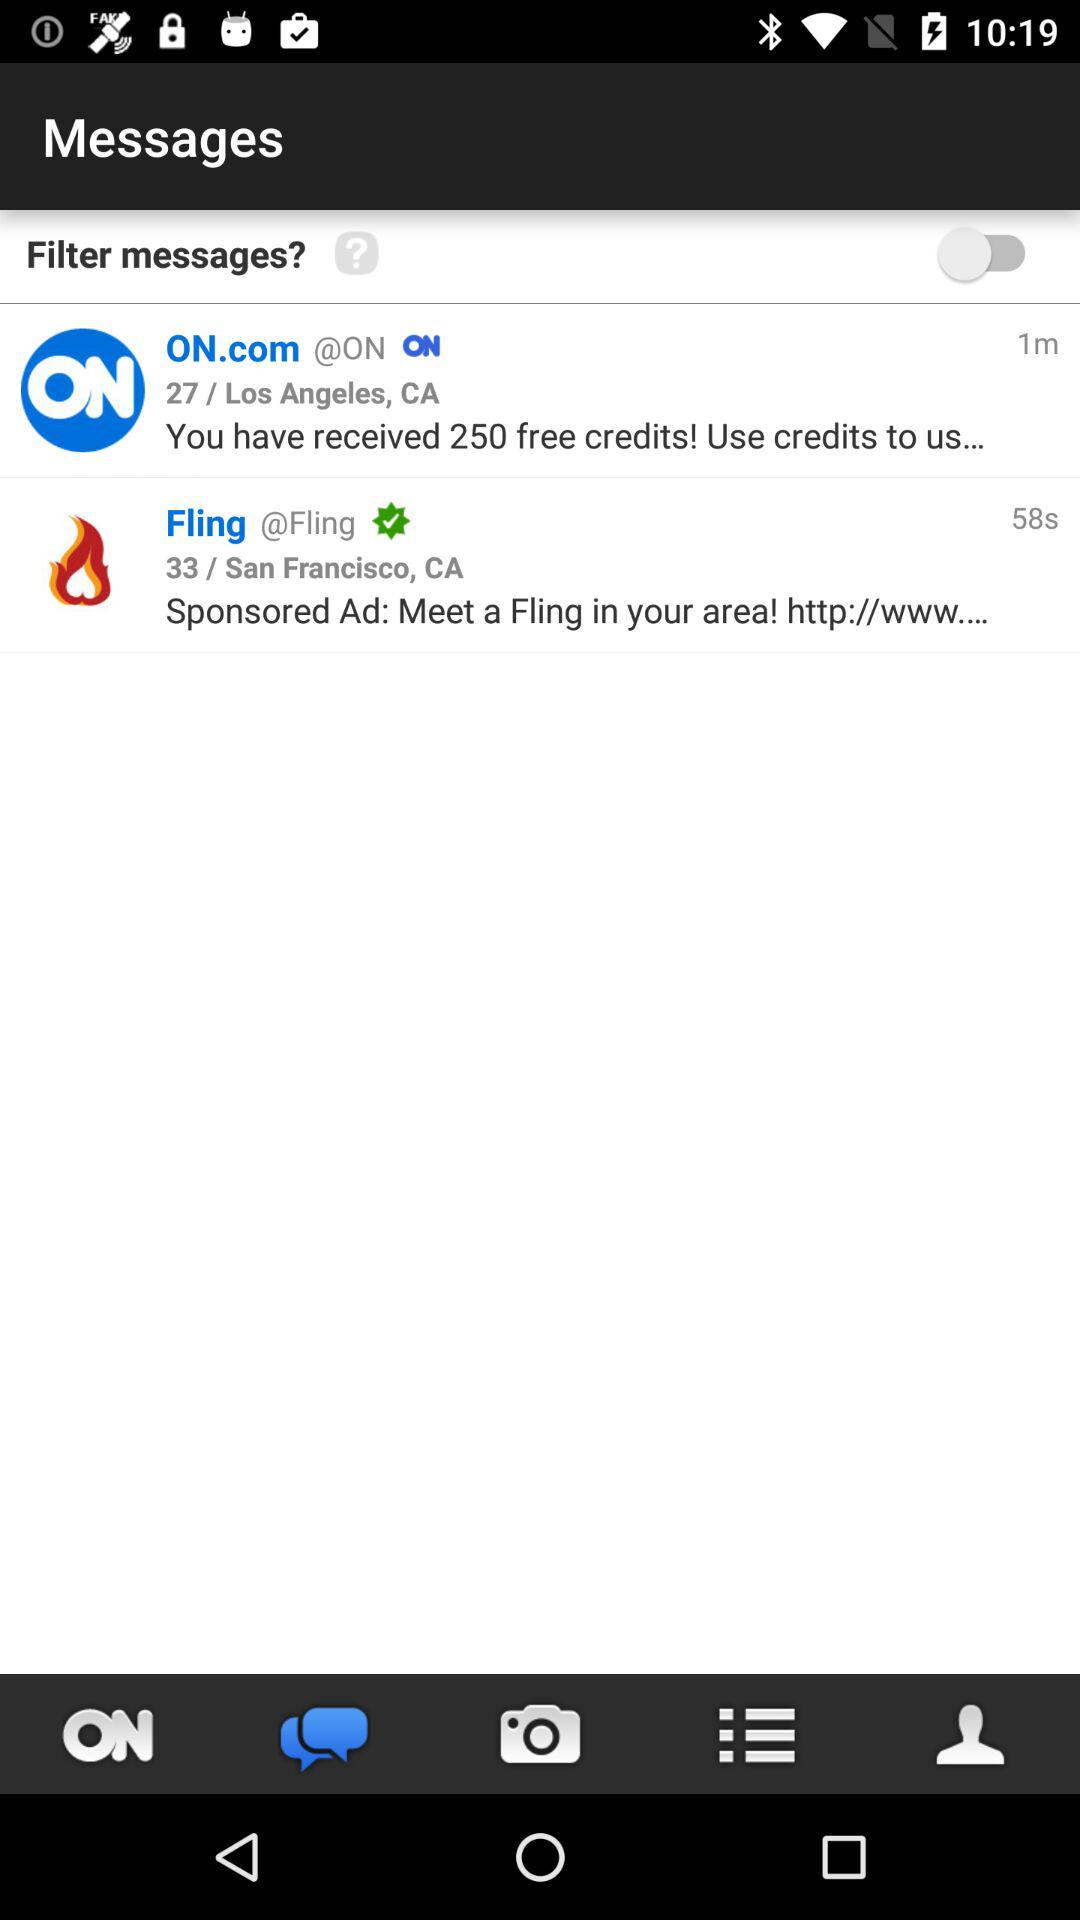What is the location of the message "Fling"? The location is 33 / San Francisco, CA. 